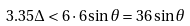Convert formula to latex. <formula><loc_0><loc_0><loc_500><loc_500>3 . 3 5 \Delta < 6 \cdot 6 \sin \theta = 3 6 \sin \theta</formula> 